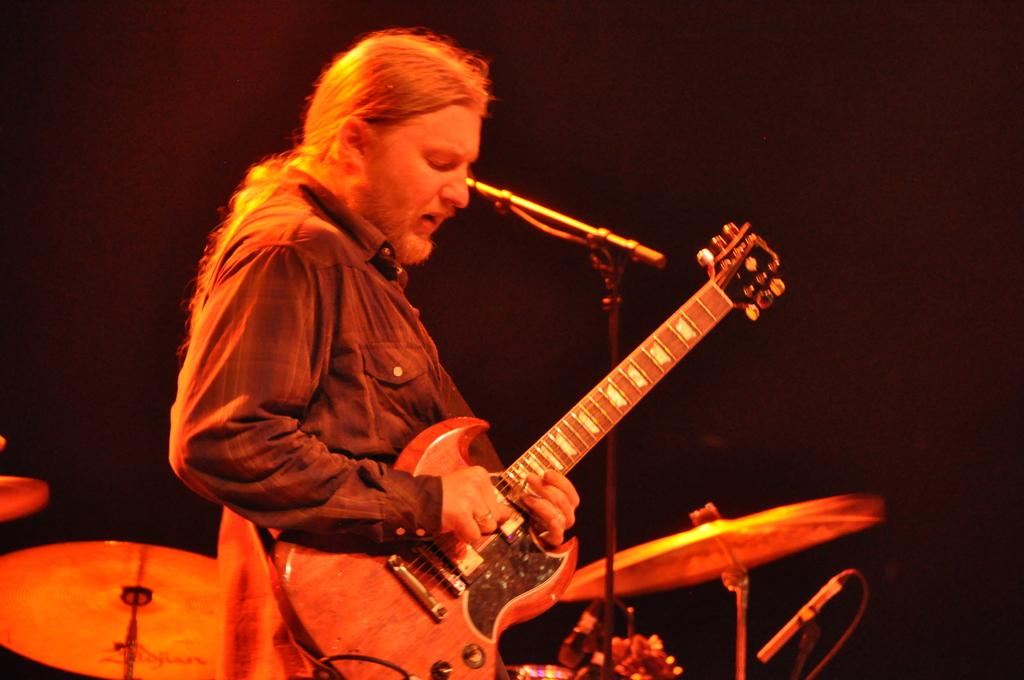What is the main subject of the image? There is a person in the image. What is the person doing in the image? The person is playing a guitar. What is the person wearing in the image? The person is wearing a shirt. What can be seen in the background of the image? There are musical instruments in the background. What is the color of the background in the image? The background is in black color. Can you tell me how many loaves of bread are on the table in the image? There is no table or loaves of bread present in the image. What type of recess is visible in the image? There is no recess present in the image. 